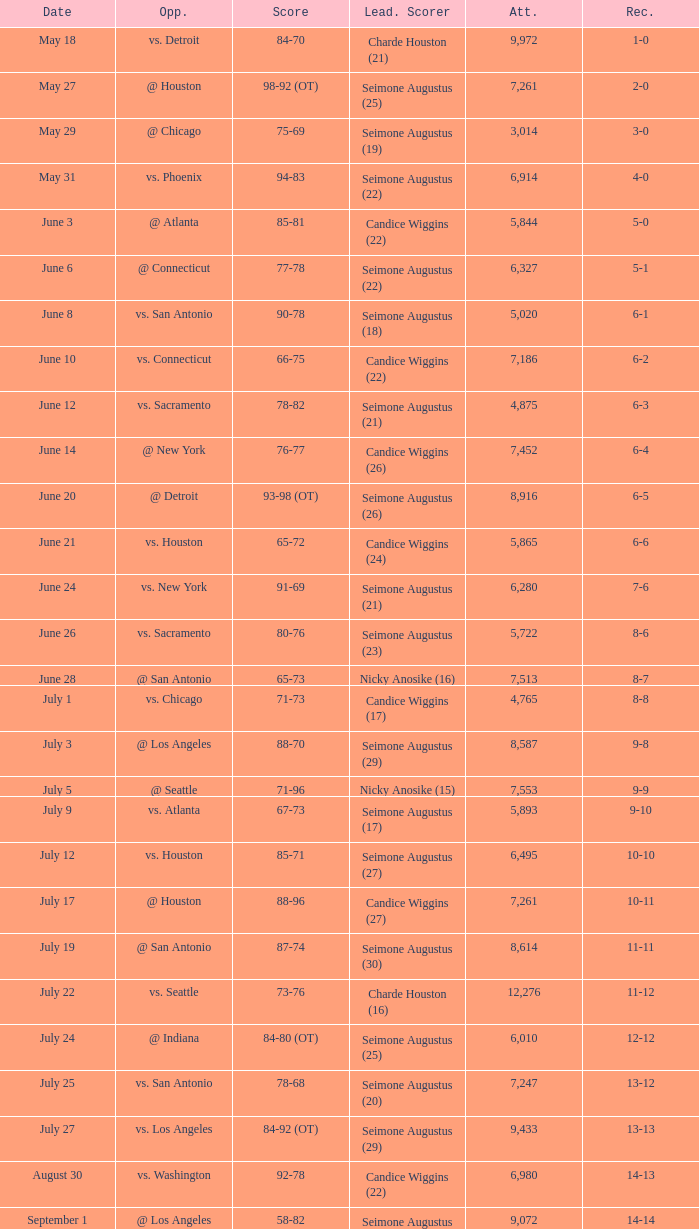Which Leading Scorer has an Opponent of @ seattle, and a Record of 14-16? Seimone Augustus (26). 